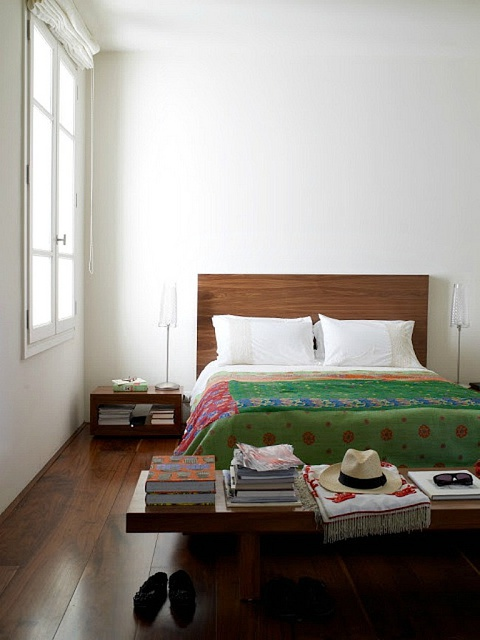Describe the objects in this image and their specific colors. I can see bed in darkgray, lightgray, maroon, and darkgreen tones, book in darkgray, gray, black, and olive tones, book in darkgray, black, and gray tones, book in darkgray, gray, and black tones, and book in darkgray, gray, and black tones in this image. 